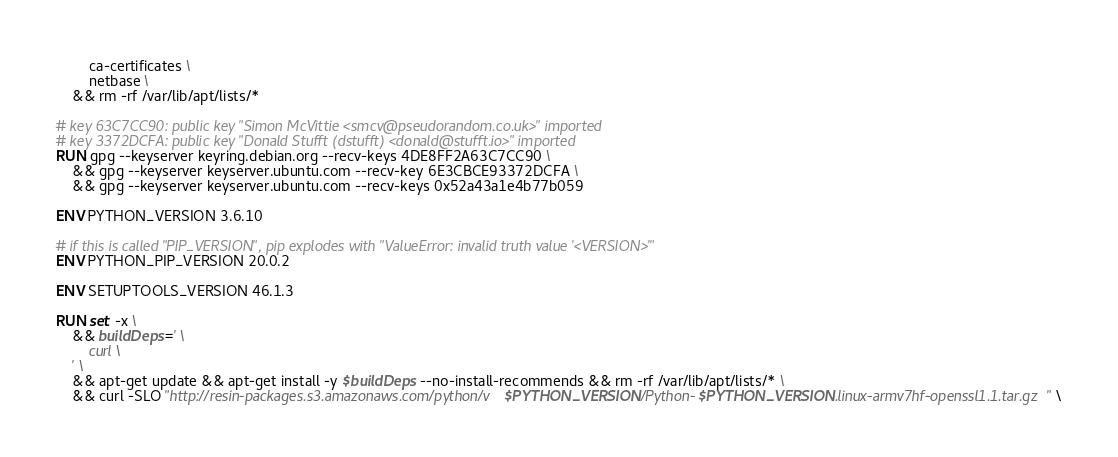<code> <loc_0><loc_0><loc_500><loc_500><_Dockerfile_>		ca-certificates \
		netbase \
	&& rm -rf /var/lib/apt/lists/*

# key 63C7CC90: public key "Simon McVittie <smcv@pseudorandom.co.uk>" imported
# key 3372DCFA: public key "Donald Stufft (dstufft) <donald@stufft.io>" imported
RUN gpg --keyserver keyring.debian.org --recv-keys 4DE8FF2A63C7CC90 \
	&& gpg --keyserver keyserver.ubuntu.com --recv-key 6E3CBCE93372DCFA \
	&& gpg --keyserver keyserver.ubuntu.com --recv-keys 0x52a43a1e4b77b059

ENV PYTHON_VERSION 3.6.10

# if this is called "PIP_VERSION", pip explodes with "ValueError: invalid truth value '<VERSION>'"
ENV PYTHON_PIP_VERSION 20.0.2

ENV SETUPTOOLS_VERSION 46.1.3

RUN set -x \
	&& buildDeps=' \
		curl \
	' \
	&& apt-get update && apt-get install -y $buildDeps --no-install-recommends && rm -rf /var/lib/apt/lists/* \
	&& curl -SLO "http://resin-packages.s3.amazonaws.com/python/v$PYTHON_VERSION/Python-$PYTHON_VERSION.linux-armv7hf-openssl1.1.tar.gz" \</code> 